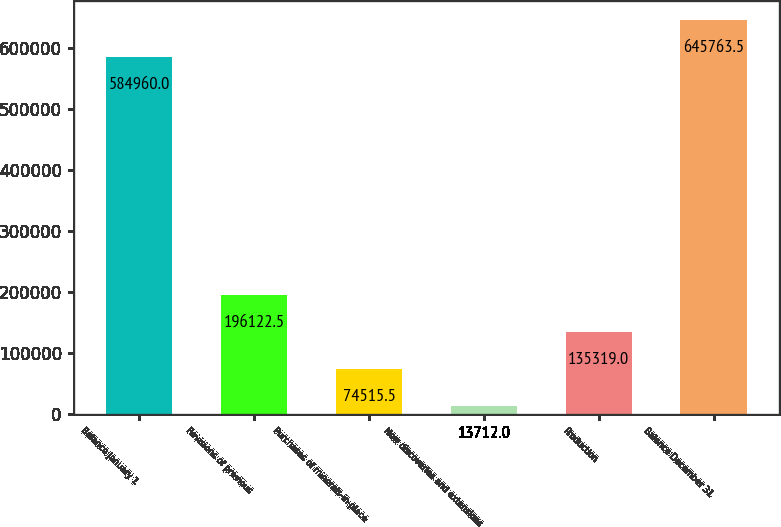Convert chart. <chart><loc_0><loc_0><loc_500><loc_500><bar_chart><fcel>Balance January 1<fcel>Revisions of previous<fcel>Purchases of minerals-in-place<fcel>New discoveries and extensions<fcel>Production<fcel>Balance December 31<nl><fcel>584960<fcel>196122<fcel>74515.5<fcel>13712<fcel>135319<fcel>645764<nl></chart> 